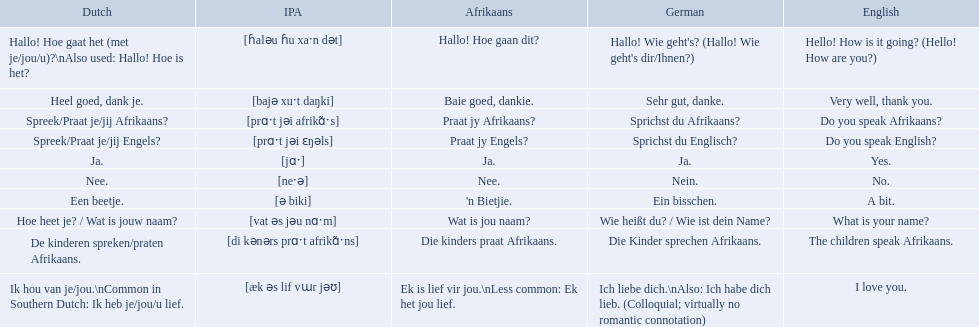In german how do you say do you speak afrikaans? Sprichst du Afrikaans?. How do you say it in afrikaans? Praat jy Afrikaans?. 